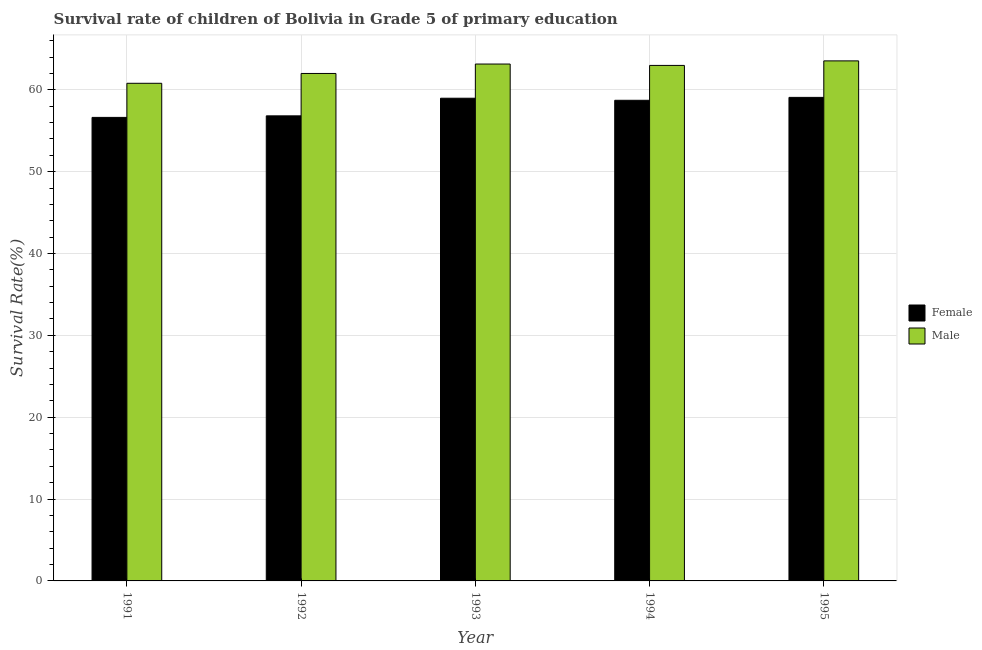How many groups of bars are there?
Make the answer very short. 5. In how many cases, is the number of bars for a given year not equal to the number of legend labels?
Provide a succinct answer. 0. What is the survival rate of male students in primary education in 1995?
Provide a succinct answer. 63.53. Across all years, what is the maximum survival rate of female students in primary education?
Make the answer very short. 59.07. Across all years, what is the minimum survival rate of male students in primary education?
Keep it short and to the point. 60.79. In which year was the survival rate of male students in primary education minimum?
Make the answer very short. 1991. What is the total survival rate of male students in primary education in the graph?
Provide a succinct answer. 312.44. What is the difference between the survival rate of female students in primary education in 1991 and that in 1995?
Ensure brevity in your answer.  -2.45. What is the difference between the survival rate of female students in primary education in 1992 and the survival rate of male students in primary education in 1993?
Offer a terse response. -2.15. What is the average survival rate of female students in primary education per year?
Your answer should be very brief. 58.04. In how many years, is the survival rate of female students in primary education greater than 48 %?
Provide a short and direct response. 5. What is the ratio of the survival rate of female students in primary education in 1991 to that in 1992?
Provide a short and direct response. 1. What is the difference between the highest and the second highest survival rate of male students in primary education?
Your response must be concise. 0.39. What is the difference between the highest and the lowest survival rate of female students in primary education?
Offer a very short reply. 2.45. Is the sum of the survival rate of female students in primary education in 1991 and 1992 greater than the maximum survival rate of male students in primary education across all years?
Provide a short and direct response. Yes. What does the 2nd bar from the left in 1994 represents?
Provide a succinct answer. Male. How many bars are there?
Your response must be concise. 10. What is the difference between two consecutive major ticks on the Y-axis?
Ensure brevity in your answer.  10. Are the values on the major ticks of Y-axis written in scientific E-notation?
Make the answer very short. No. How many legend labels are there?
Ensure brevity in your answer.  2. What is the title of the graph?
Ensure brevity in your answer.  Survival rate of children of Bolivia in Grade 5 of primary education. What is the label or title of the Y-axis?
Your answer should be very brief. Survival Rate(%). What is the Survival Rate(%) of Female in 1991?
Your answer should be very brief. 56.63. What is the Survival Rate(%) of Male in 1991?
Offer a terse response. 60.79. What is the Survival Rate(%) in Female in 1992?
Ensure brevity in your answer.  56.81. What is the Survival Rate(%) in Male in 1992?
Provide a succinct answer. 61.99. What is the Survival Rate(%) in Female in 1993?
Provide a succinct answer. 58.97. What is the Survival Rate(%) in Male in 1993?
Ensure brevity in your answer.  63.14. What is the Survival Rate(%) in Female in 1994?
Your response must be concise. 58.72. What is the Survival Rate(%) in Male in 1994?
Your response must be concise. 62.98. What is the Survival Rate(%) in Female in 1995?
Give a very brief answer. 59.07. What is the Survival Rate(%) of Male in 1995?
Offer a very short reply. 63.53. Across all years, what is the maximum Survival Rate(%) of Female?
Offer a terse response. 59.07. Across all years, what is the maximum Survival Rate(%) in Male?
Ensure brevity in your answer.  63.53. Across all years, what is the minimum Survival Rate(%) in Female?
Your answer should be very brief. 56.63. Across all years, what is the minimum Survival Rate(%) of Male?
Your response must be concise. 60.79. What is the total Survival Rate(%) in Female in the graph?
Provide a short and direct response. 290.2. What is the total Survival Rate(%) of Male in the graph?
Ensure brevity in your answer.  312.44. What is the difference between the Survival Rate(%) of Female in 1991 and that in 1992?
Offer a terse response. -0.19. What is the difference between the Survival Rate(%) in Male in 1991 and that in 1992?
Provide a short and direct response. -1.2. What is the difference between the Survival Rate(%) in Female in 1991 and that in 1993?
Your response must be concise. -2.34. What is the difference between the Survival Rate(%) in Male in 1991 and that in 1993?
Give a very brief answer. -2.35. What is the difference between the Survival Rate(%) of Female in 1991 and that in 1994?
Your response must be concise. -2.09. What is the difference between the Survival Rate(%) in Male in 1991 and that in 1994?
Offer a very short reply. -2.18. What is the difference between the Survival Rate(%) in Female in 1991 and that in 1995?
Your answer should be very brief. -2.45. What is the difference between the Survival Rate(%) in Male in 1991 and that in 1995?
Provide a short and direct response. -2.74. What is the difference between the Survival Rate(%) of Female in 1992 and that in 1993?
Give a very brief answer. -2.15. What is the difference between the Survival Rate(%) of Male in 1992 and that in 1993?
Provide a short and direct response. -1.15. What is the difference between the Survival Rate(%) of Female in 1992 and that in 1994?
Your response must be concise. -1.9. What is the difference between the Survival Rate(%) of Male in 1992 and that in 1994?
Offer a very short reply. -0.98. What is the difference between the Survival Rate(%) in Female in 1992 and that in 1995?
Give a very brief answer. -2.26. What is the difference between the Survival Rate(%) of Male in 1992 and that in 1995?
Ensure brevity in your answer.  -1.54. What is the difference between the Survival Rate(%) in Female in 1993 and that in 1994?
Make the answer very short. 0.25. What is the difference between the Survival Rate(%) in Male in 1993 and that in 1994?
Provide a succinct answer. 0.17. What is the difference between the Survival Rate(%) in Female in 1993 and that in 1995?
Ensure brevity in your answer.  -0.1. What is the difference between the Survival Rate(%) of Male in 1993 and that in 1995?
Keep it short and to the point. -0.39. What is the difference between the Survival Rate(%) of Female in 1994 and that in 1995?
Provide a short and direct response. -0.36. What is the difference between the Survival Rate(%) of Male in 1994 and that in 1995?
Offer a terse response. -0.55. What is the difference between the Survival Rate(%) of Female in 1991 and the Survival Rate(%) of Male in 1992?
Offer a terse response. -5.37. What is the difference between the Survival Rate(%) in Female in 1991 and the Survival Rate(%) in Male in 1993?
Offer a very short reply. -6.52. What is the difference between the Survival Rate(%) of Female in 1991 and the Survival Rate(%) of Male in 1994?
Keep it short and to the point. -6.35. What is the difference between the Survival Rate(%) of Female in 1991 and the Survival Rate(%) of Male in 1995?
Ensure brevity in your answer.  -6.9. What is the difference between the Survival Rate(%) in Female in 1992 and the Survival Rate(%) in Male in 1993?
Offer a very short reply. -6.33. What is the difference between the Survival Rate(%) of Female in 1992 and the Survival Rate(%) of Male in 1994?
Offer a terse response. -6.16. What is the difference between the Survival Rate(%) of Female in 1992 and the Survival Rate(%) of Male in 1995?
Ensure brevity in your answer.  -6.72. What is the difference between the Survival Rate(%) of Female in 1993 and the Survival Rate(%) of Male in 1994?
Offer a terse response. -4.01. What is the difference between the Survival Rate(%) in Female in 1993 and the Survival Rate(%) in Male in 1995?
Give a very brief answer. -4.56. What is the difference between the Survival Rate(%) of Female in 1994 and the Survival Rate(%) of Male in 1995?
Your answer should be very brief. -4.82. What is the average Survival Rate(%) of Female per year?
Provide a short and direct response. 58.04. What is the average Survival Rate(%) of Male per year?
Provide a succinct answer. 62.49. In the year 1991, what is the difference between the Survival Rate(%) in Female and Survival Rate(%) in Male?
Keep it short and to the point. -4.17. In the year 1992, what is the difference between the Survival Rate(%) of Female and Survival Rate(%) of Male?
Provide a succinct answer. -5.18. In the year 1993, what is the difference between the Survival Rate(%) in Female and Survival Rate(%) in Male?
Ensure brevity in your answer.  -4.18. In the year 1994, what is the difference between the Survival Rate(%) in Female and Survival Rate(%) in Male?
Ensure brevity in your answer.  -4.26. In the year 1995, what is the difference between the Survival Rate(%) of Female and Survival Rate(%) of Male?
Provide a short and direct response. -4.46. What is the ratio of the Survival Rate(%) in Female in 1991 to that in 1992?
Make the answer very short. 1. What is the ratio of the Survival Rate(%) of Male in 1991 to that in 1992?
Give a very brief answer. 0.98. What is the ratio of the Survival Rate(%) in Female in 1991 to that in 1993?
Offer a terse response. 0.96. What is the ratio of the Survival Rate(%) of Male in 1991 to that in 1993?
Provide a succinct answer. 0.96. What is the ratio of the Survival Rate(%) of Female in 1991 to that in 1994?
Offer a very short reply. 0.96. What is the ratio of the Survival Rate(%) of Male in 1991 to that in 1994?
Make the answer very short. 0.97. What is the ratio of the Survival Rate(%) in Female in 1991 to that in 1995?
Your answer should be compact. 0.96. What is the ratio of the Survival Rate(%) in Male in 1991 to that in 1995?
Ensure brevity in your answer.  0.96. What is the ratio of the Survival Rate(%) of Female in 1992 to that in 1993?
Make the answer very short. 0.96. What is the ratio of the Survival Rate(%) in Male in 1992 to that in 1993?
Give a very brief answer. 0.98. What is the ratio of the Survival Rate(%) of Female in 1992 to that in 1994?
Keep it short and to the point. 0.97. What is the ratio of the Survival Rate(%) in Male in 1992 to that in 1994?
Keep it short and to the point. 0.98. What is the ratio of the Survival Rate(%) of Female in 1992 to that in 1995?
Make the answer very short. 0.96. What is the ratio of the Survival Rate(%) of Male in 1992 to that in 1995?
Make the answer very short. 0.98. What is the ratio of the Survival Rate(%) in Female in 1993 to that in 1994?
Provide a short and direct response. 1. What is the ratio of the Survival Rate(%) in Male in 1993 to that in 1994?
Your answer should be compact. 1. What is the difference between the highest and the second highest Survival Rate(%) in Female?
Your response must be concise. 0.1. What is the difference between the highest and the second highest Survival Rate(%) in Male?
Your answer should be very brief. 0.39. What is the difference between the highest and the lowest Survival Rate(%) in Female?
Provide a succinct answer. 2.45. What is the difference between the highest and the lowest Survival Rate(%) of Male?
Provide a succinct answer. 2.74. 